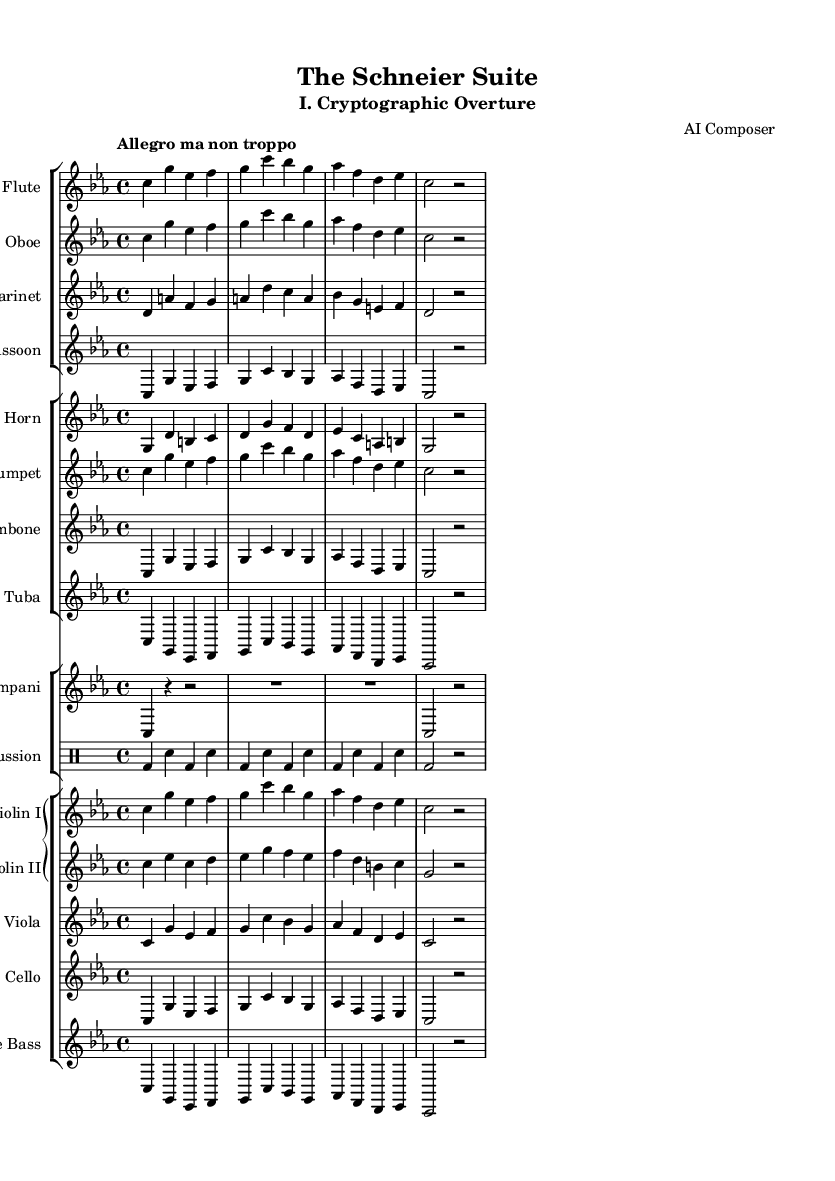What is the key signature of this music? The key signature is C minor, indicated by the presence of three flats (B flat, E flat, and A flat) at the beginning of the score.
Answer: C minor What is the time signature of this music? The time signature is indicated at the beginning of the score as 4/4, which means there are four beats in each measure and the quarter note gets one beat.
Answer: 4/4 What is the tempo marking of this music? The tempo marking appears in the score as "Allegro ma non troppo", which indicates a fast tempo, but not too fast.
Answer: Allegro ma non troppo How many instruments are featured in this symphony? By counting the distinct staves in the score, there are a total of 14 instruments listed, including woodwinds, brass, percussion, and strings.
Answer: 14 instruments Which sections are present in the score? The score includes sections for woodwinds, brass, percussion, and strings, as indicated by the groupings in the score layout.
Answer: Woodwinds, Brass, Percussion, Strings What is the highest instrument in pitch in this piece? The flute is typically the highest-pitched instrument shown in the score, as it plays notes in the highest range compared to the other instruments.
Answer: Flute Which instrument has a transposition indicated in the part? The clarinet has a transposition indicated as "bes", which shows how it is written a whole step higher than concert pitch.
Answer: Clarinet 